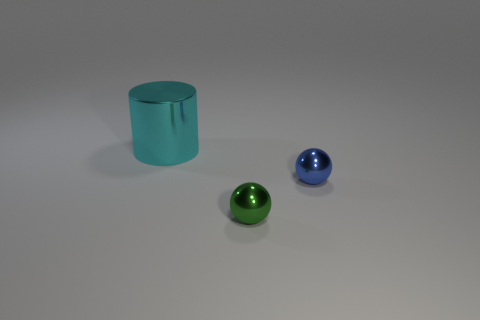Is there any other thing that has the same size as the cyan metallic object?
Provide a succinct answer. No. How many metallic balls are in front of the small metal object that is in front of the small blue shiny ball?
Your response must be concise. 0. Is the number of small blue balls that are to the left of the tiny blue shiny ball less than the number of small blue matte cylinders?
Provide a short and direct response. No. Is there a small blue metal thing behind the tiny object behind the shiny sphere that is in front of the tiny blue ball?
Your answer should be very brief. No. Do the small blue object and the small sphere in front of the tiny blue ball have the same material?
Your answer should be very brief. Yes. The metal object behind the tiny shiny sphere right of the small green ball is what color?
Your answer should be compact. Cyan. Are there any other metal cylinders of the same color as the big cylinder?
Offer a terse response. No. There is a object that is behind the small shiny sphere to the right of the small object that is left of the blue metallic thing; what size is it?
Offer a very short reply. Large. There is a small green thing; does it have the same shape as the object behind the tiny blue metal thing?
Offer a terse response. No. How many other things are the same size as the green thing?
Your answer should be very brief. 1. 